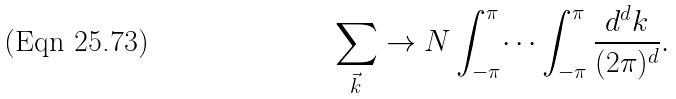Convert formula to latex. <formula><loc_0><loc_0><loc_500><loc_500>\sum _ { \vec { k } } \rightarrow N \int _ { - \pi } ^ { \pi } \dots \int _ { - \pi } ^ { \pi } \frac { d ^ { d } k } { ( 2 \pi ) ^ { d } } .</formula> 